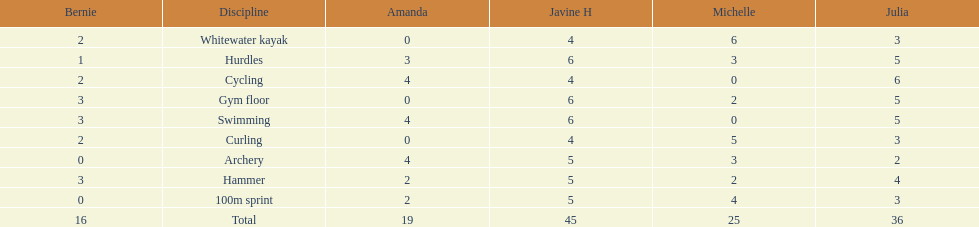Which of the girls had the least amount in archery? Bernie. 